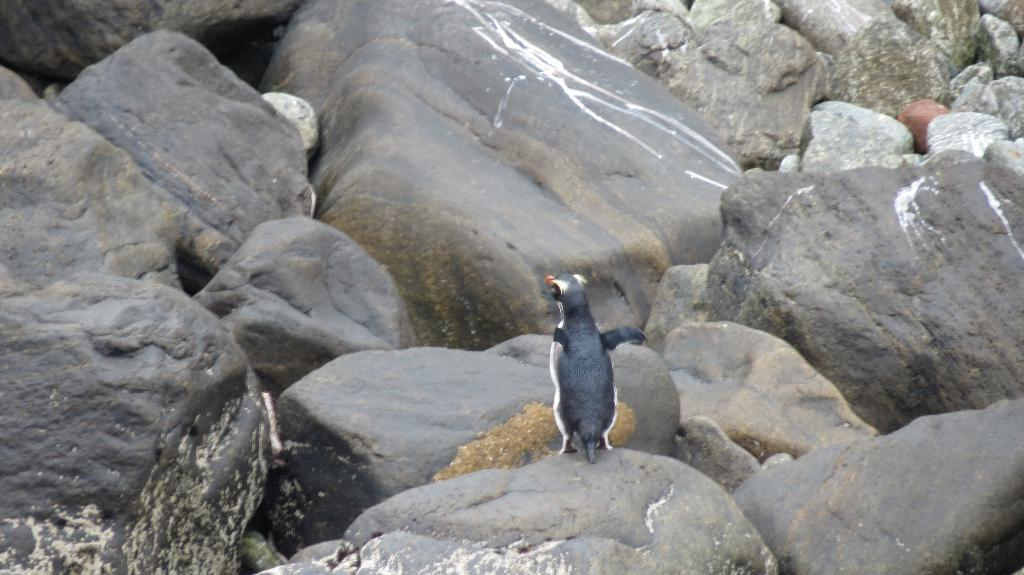What is the main subject of the image? There is an animal on a rock at the bottom of the image. Can you describe the rocks in the image? There is a rock on the left side of the image, another rock on the right side of the image, and rocks visible in the background of the image. What type of feather can be seen on the animal in the image? There is no feather visible on the animal in the image. How does the vessel help the animal in the image? There is no vessel present in the image, so it cannot help the animal. 